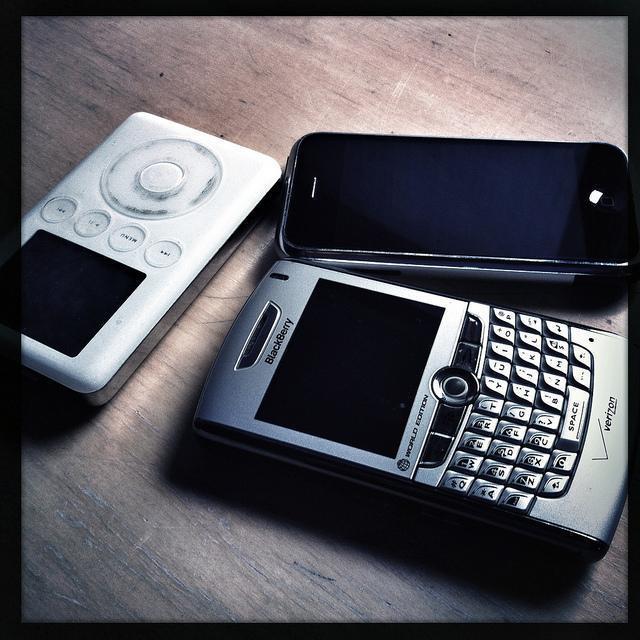How many phones are these?
Give a very brief answer. 2. How many cell phones are there?
Give a very brief answer. 3. 